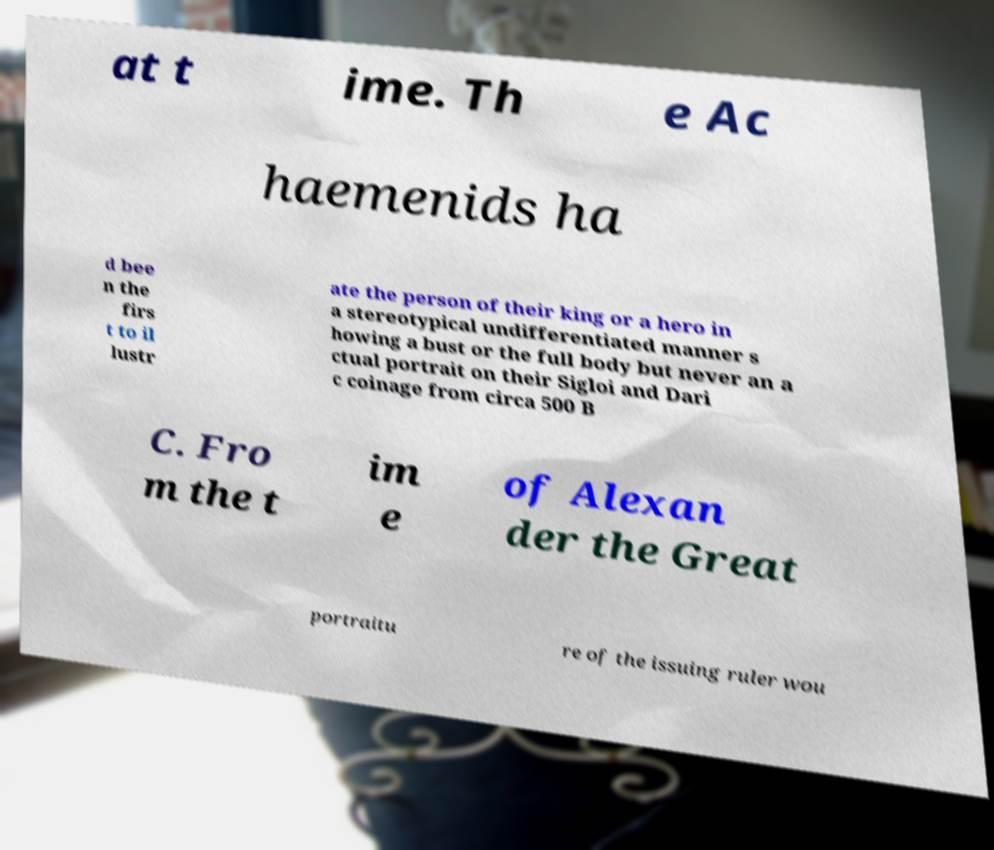Can you accurately transcribe the text from the provided image for me? at t ime. Th e Ac haemenids ha d bee n the firs t to il lustr ate the person of their king or a hero in a stereotypical undifferentiated manner s howing a bust or the full body but never an a ctual portrait on their Sigloi and Dari c coinage from circa 500 B C. Fro m the t im e of Alexan der the Great portraitu re of the issuing ruler wou 